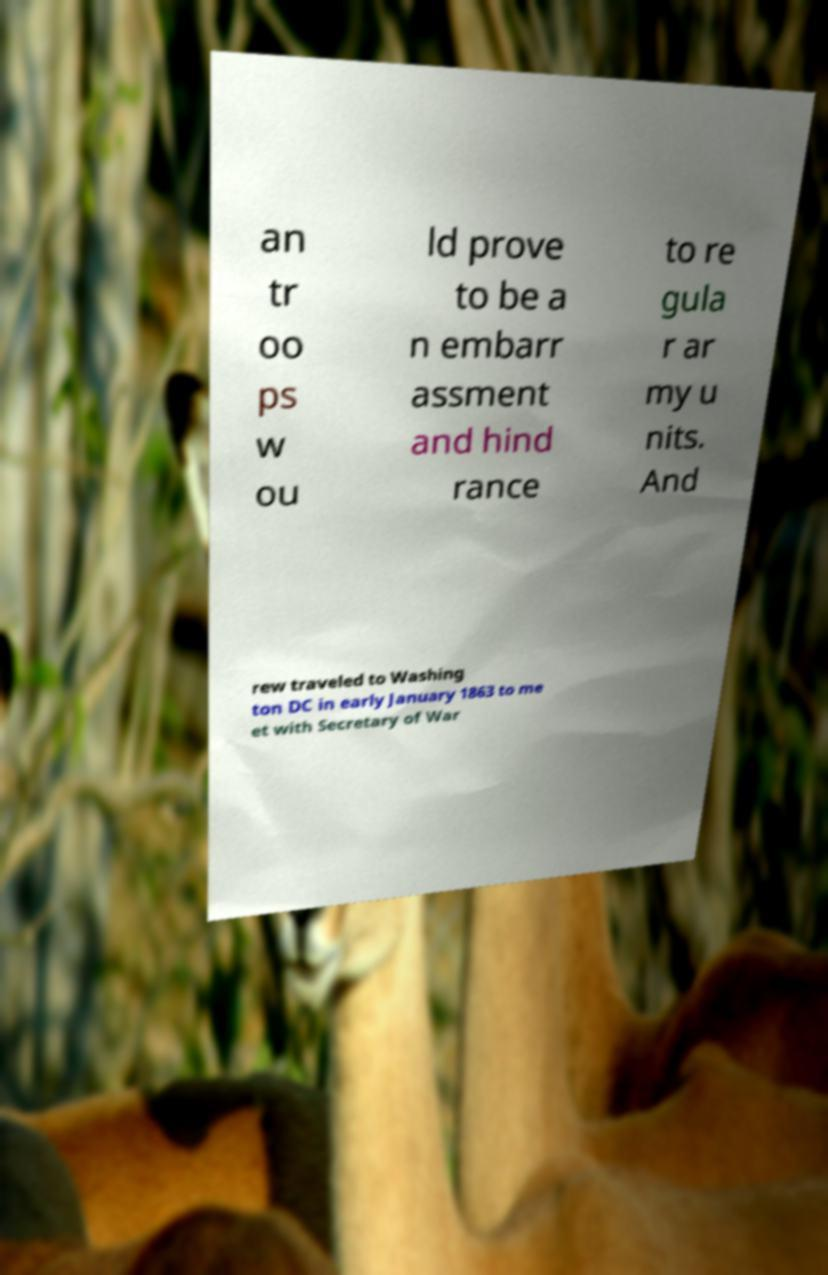I need the written content from this picture converted into text. Can you do that? an tr oo ps w ou ld prove to be a n embarr assment and hind rance to re gula r ar my u nits. And rew traveled to Washing ton DC in early January 1863 to me et with Secretary of War 